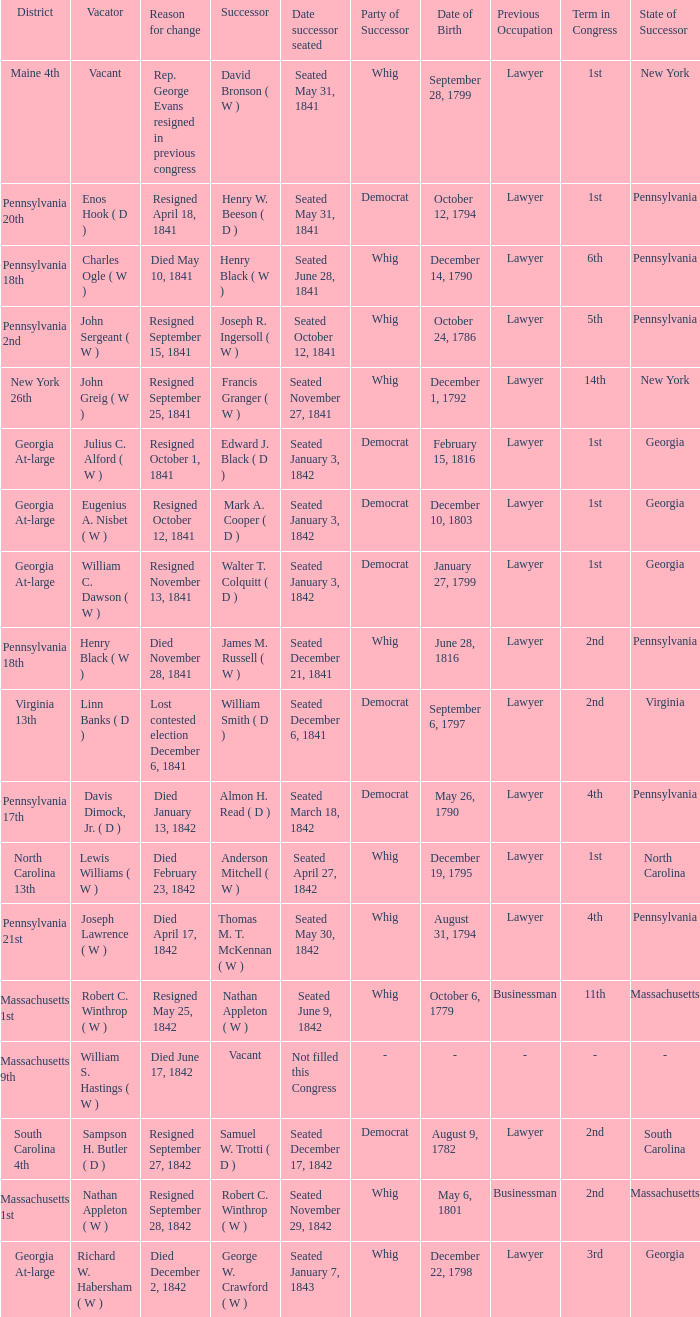Name the successor for north carolina 13th Anderson Mitchell ( W ). 